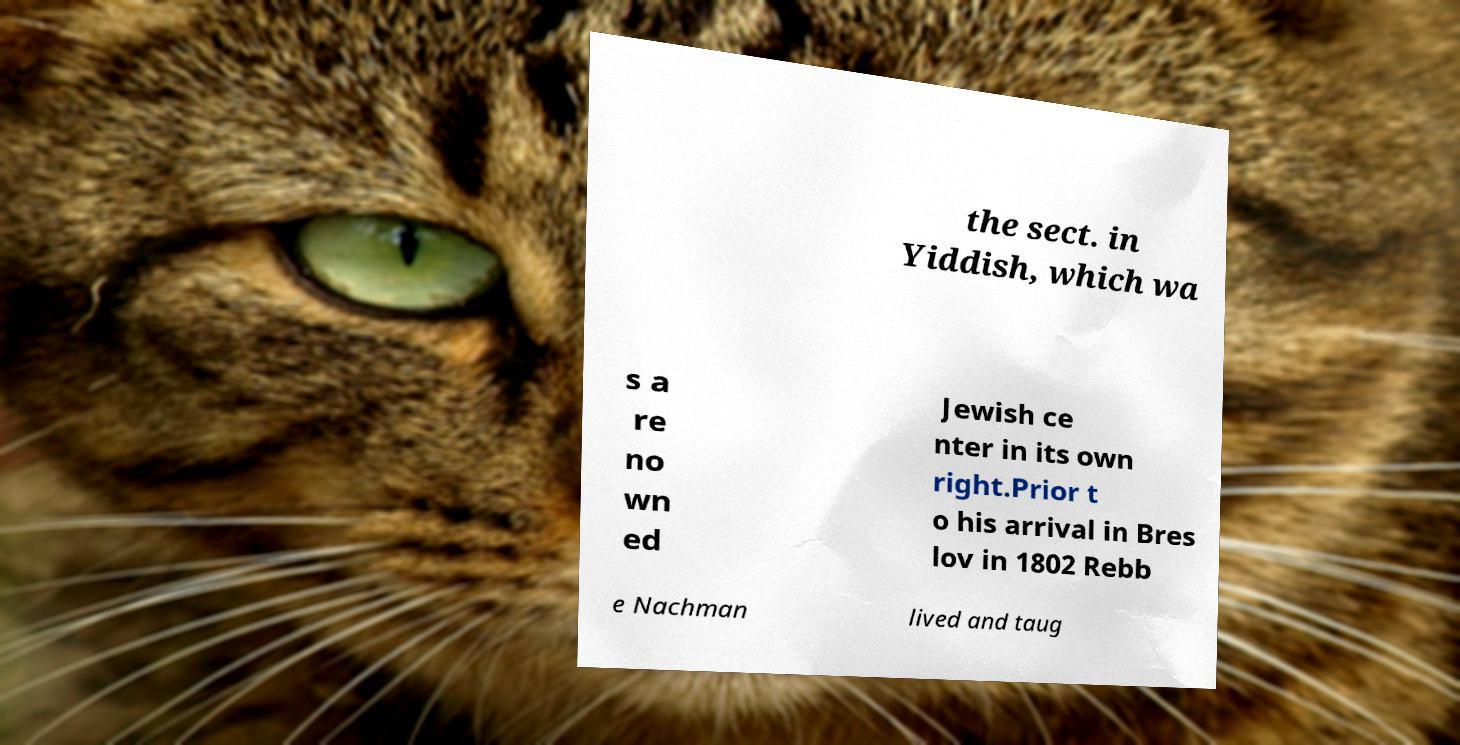Please read and relay the text visible in this image. What does it say? the sect. in Yiddish, which wa s a re no wn ed Jewish ce nter in its own right.Prior t o his arrival in Bres lov in 1802 Rebb e Nachman lived and taug 